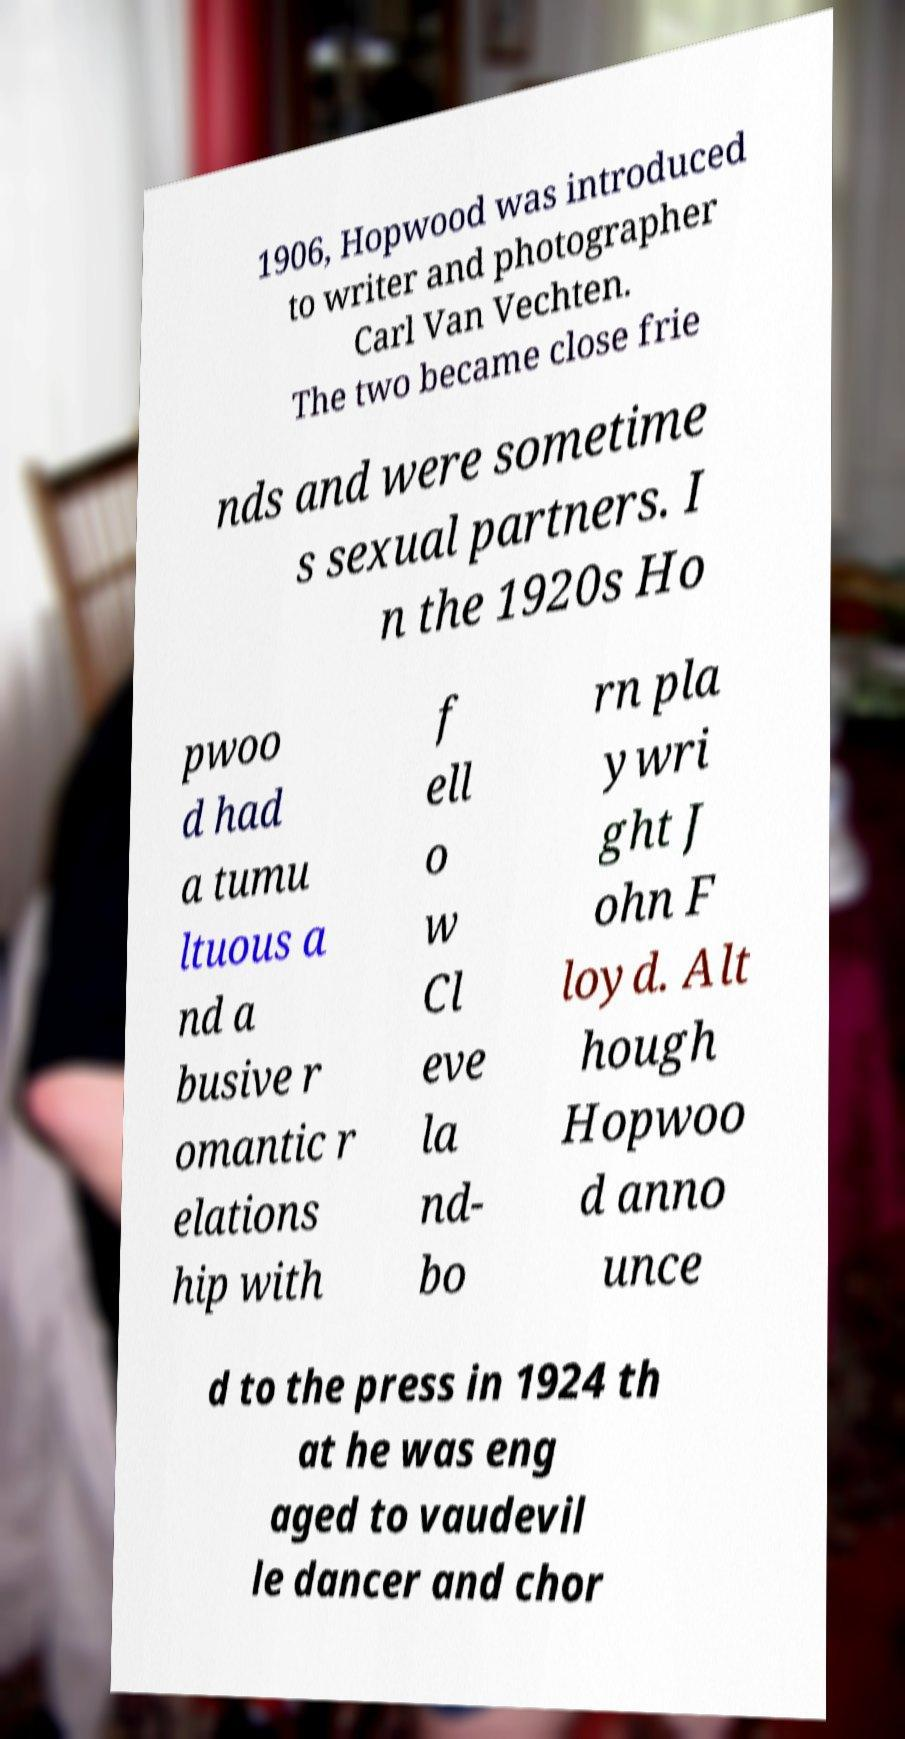For documentation purposes, I need the text within this image transcribed. Could you provide that? 1906, Hopwood was introduced to writer and photographer Carl Van Vechten. The two became close frie nds and were sometime s sexual partners. I n the 1920s Ho pwoo d had a tumu ltuous a nd a busive r omantic r elations hip with f ell o w Cl eve la nd- bo rn pla ywri ght J ohn F loyd. Alt hough Hopwoo d anno unce d to the press in 1924 th at he was eng aged to vaudevil le dancer and chor 